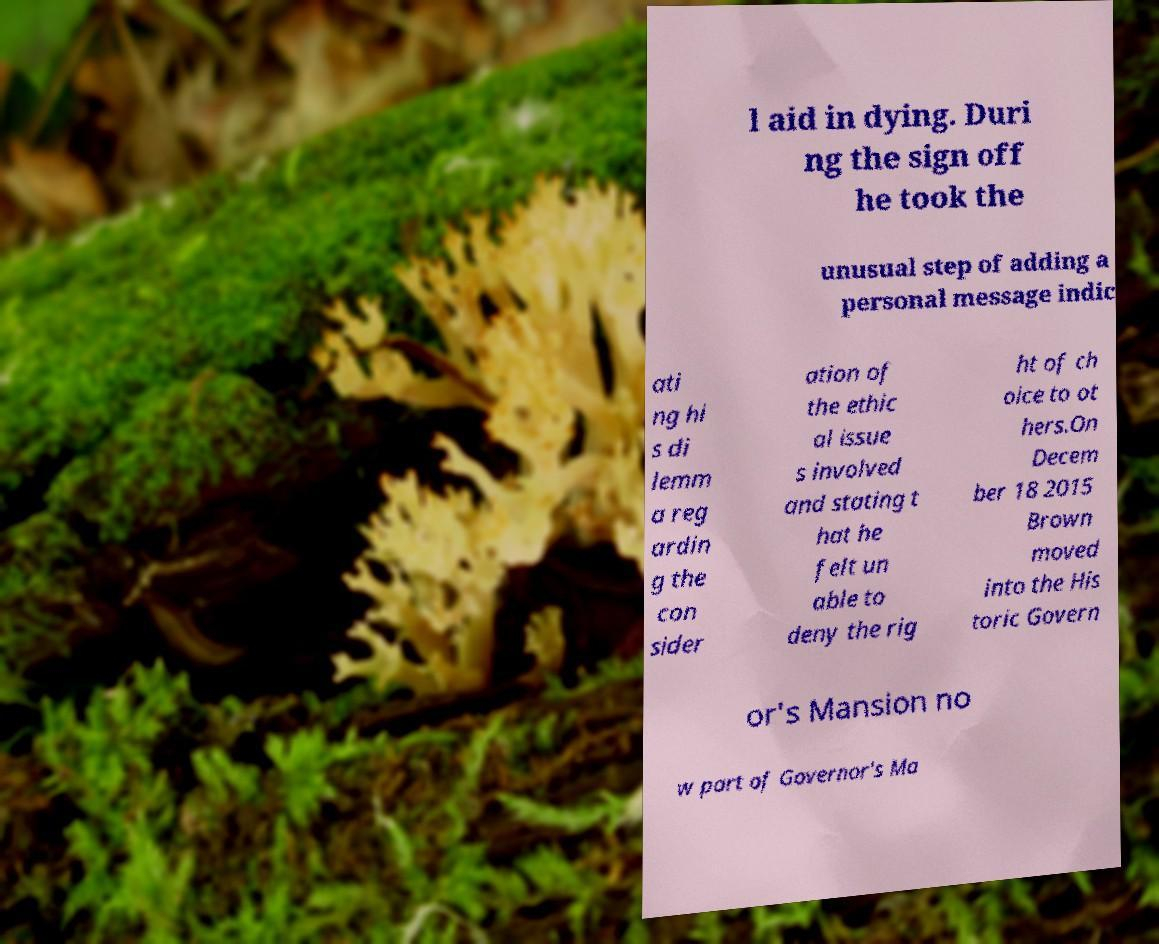There's text embedded in this image that I need extracted. Can you transcribe it verbatim? l aid in dying. Duri ng the sign off he took the unusual step of adding a personal message indic ati ng hi s di lemm a reg ardin g the con sider ation of the ethic al issue s involved and stating t hat he felt un able to deny the rig ht of ch oice to ot hers.On Decem ber 18 2015 Brown moved into the His toric Govern or's Mansion no w part of Governor's Ma 